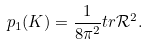Convert formula to latex. <formula><loc_0><loc_0><loc_500><loc_500>p _ { 1 } ( K ) = \frac { 1 } { 8 \pi ^ { 2 } } t r \mathcal { R } ^ { 2 } .</formula> 